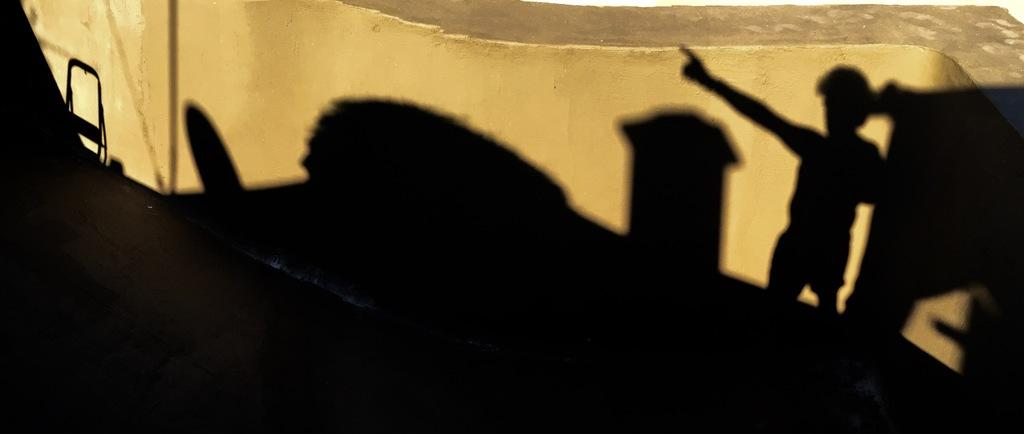What type of shadow can be seen in the image? There are shadows of a building, a person, a chair, and a pole in the image. What is visible at the top of the image? There is a wall visible at the top of the image. What type of locket is hanging from the pole in the image? There is no locket present in the image; it only features shadows and a wall. What message of hope can be seen in the image? There is no message of hope present in the image; it only features shadows and a wall. 